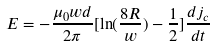Convert formula to latex. <formula><loc_0><loc_0><loc_500><loc_500>E = - \frac { \mu _ { 0 } w d } { 2 \pi } [ \ln ( \frac { 8 R } { w } ) - \frac { 1 } { 2 } ] \frac { d j _ { c } } { d t }</formula> 